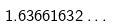Convert formula to latex. <formula><loc_0><loc_0><loc_500><loc_500>1 . 6 3 6 6 1 6 3 2 \dots</formula> 